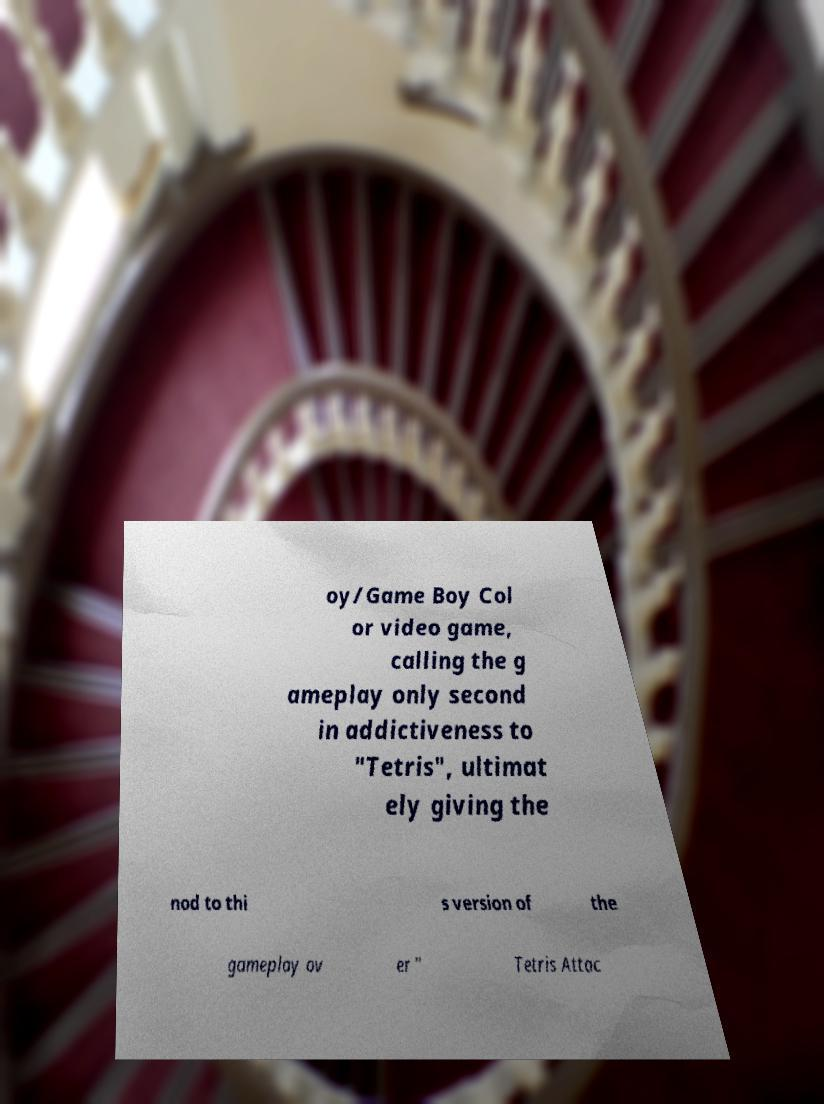Can you read and provide the text displayed in the image?This photo seems to have some interesting text. Can you extract and type it out for me? oy/Game Boy Col or video game, calling the g ameplay only second in addictiveness to "Tetris", ultimat ely giving the nod to thi s version of the gameplay ov er " Tetris Attac 